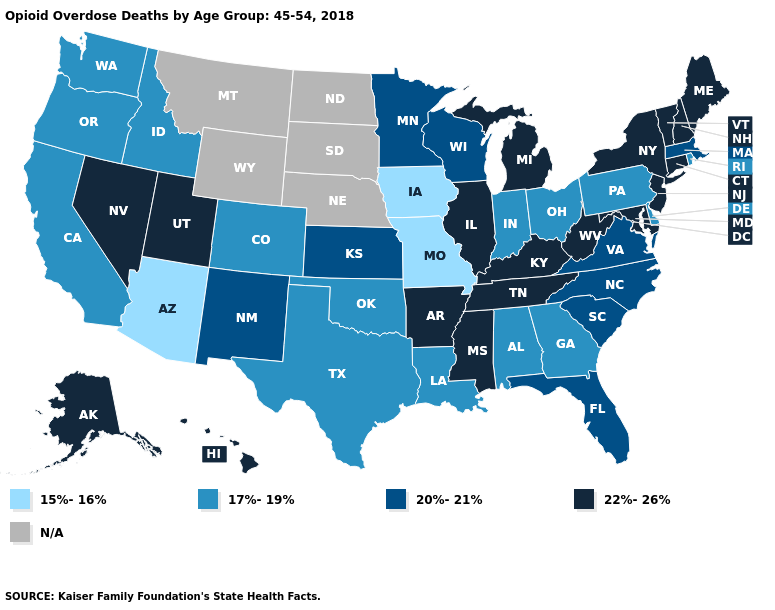Among the states that border California , which have the highest value?
Write a very short answer. Nevada. Name the states that have a value in the range N/A?
Quick response, please. Montana, Nebraska, North Dakota, South Dakota, Wyoming. Name the states that have a value in the range 22%-26%?
Give a very brief answer. Alaska, Arkansas, Connecticut, Hawaii, Illinois, Kentucky, Maine, Maryland, Michigan, Mississippi, Nevada, New Hampshire, New Jersey, New York, Tennessee, Utah, Vermont, West Virginia. Is the legend a continuous bar?
Give a very brief answer. No. Name the states that have a value in the range 20%-21%?
Give a very brief answer. Florida, Kansas, Massachusetts, Minnesota, New Mexico, North Carolina, South Carolina, Virginia, Wisconsin. Does the map have missing data?
Short answer required. Yes. Does Tennessee have the lowest value in the South?
Be succinct. No. What is the highest value in the MidWest ?
Quick response, please. 22%-26%. Name the states that have a value in the range 17%-19%?
Be succinct. Alabama, California, Colorado, Delaware, Georgia, Idaho, Indiana, Louisiana, Ohio, Oklahoma, Oregon, Pennsylvania, Rhode Island, Texas, Washington. Which states hav the highest value in the Northeast?
Keep it brief. Connecticut, Maine, New Hampshire, New Jersey, New York, Vermont. Name the states that have a value in the range 17%-19%?
Keep it brief. Alabama, California, Colorado, Delaware, Georgia, Idaho, Indiana, Louisiana, Ohio, Oklahoma, Oregon, Pennsylvania, Rhode Island, Texas, Washington. What is the highest value in the USA?
Keep it brief. 22%-26%. How many symbols are there in the legend?
Give a very brief answer. 5. Does Vermont have the lowest value in the USA?
Write a very short answer. No. 